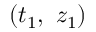Convert formula to latex. <formula><loc_0><loc_0><loc_500><loc_500>( t _ { 1 } , \ z _ { 1 } )</formula> 